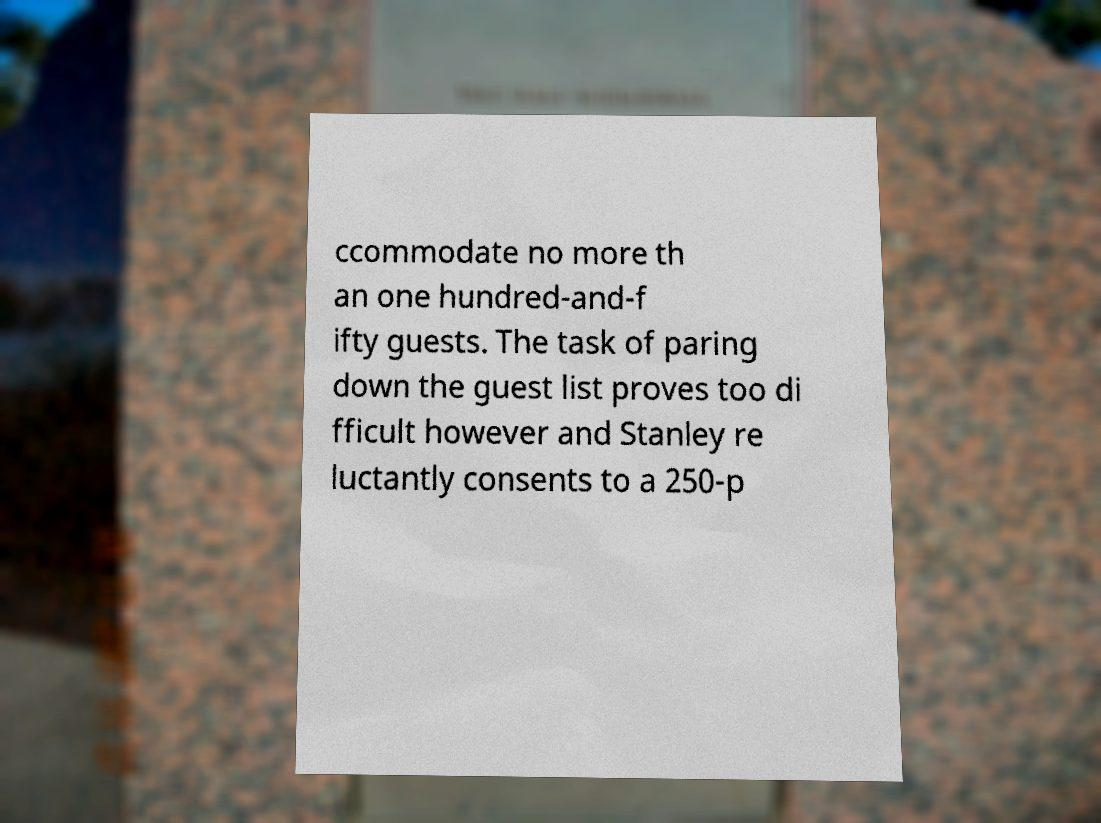For documentation purposes, I need the text within this image transcribed. Could you provide that? ccommodate no more th an one hundred-and-f ifty guests. The task of paring down the guest list proves too di fficult however and Stanley re luctantly consents to a 250-p 